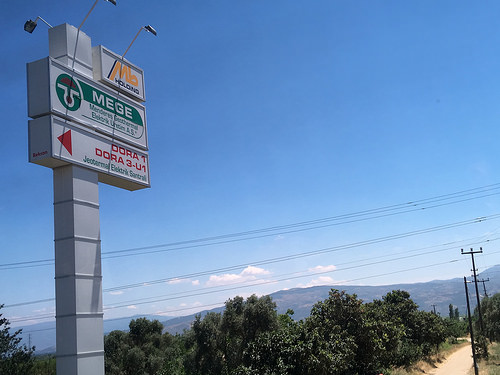<image>
Is the tree behind the road? No. The tree is not behind the road. From this viewpoint, the tree appears to be positioned elsewhere in the scene. 